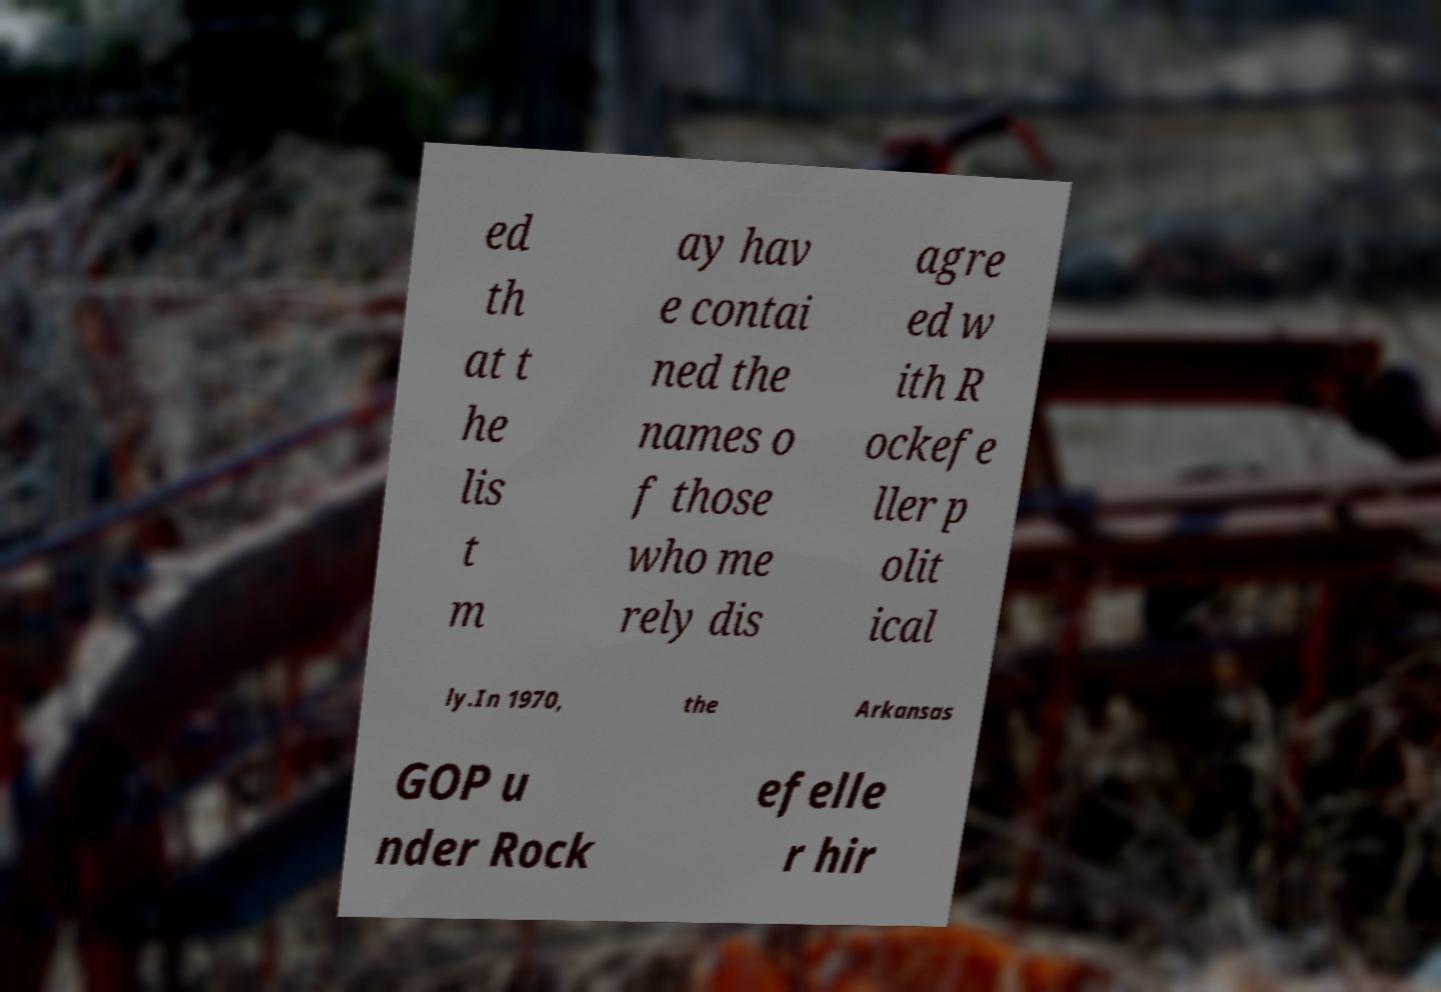There's text embedded in this image that I need extracted. Can you transcribe it verbatim? ed th at t he lis t m ay hav e contai ned the names o f those who me rely dis agre ed w ith R ockefe ller p olit ical ly.In 1970, the Arkansas GOP u nder Rock efelle r hir 